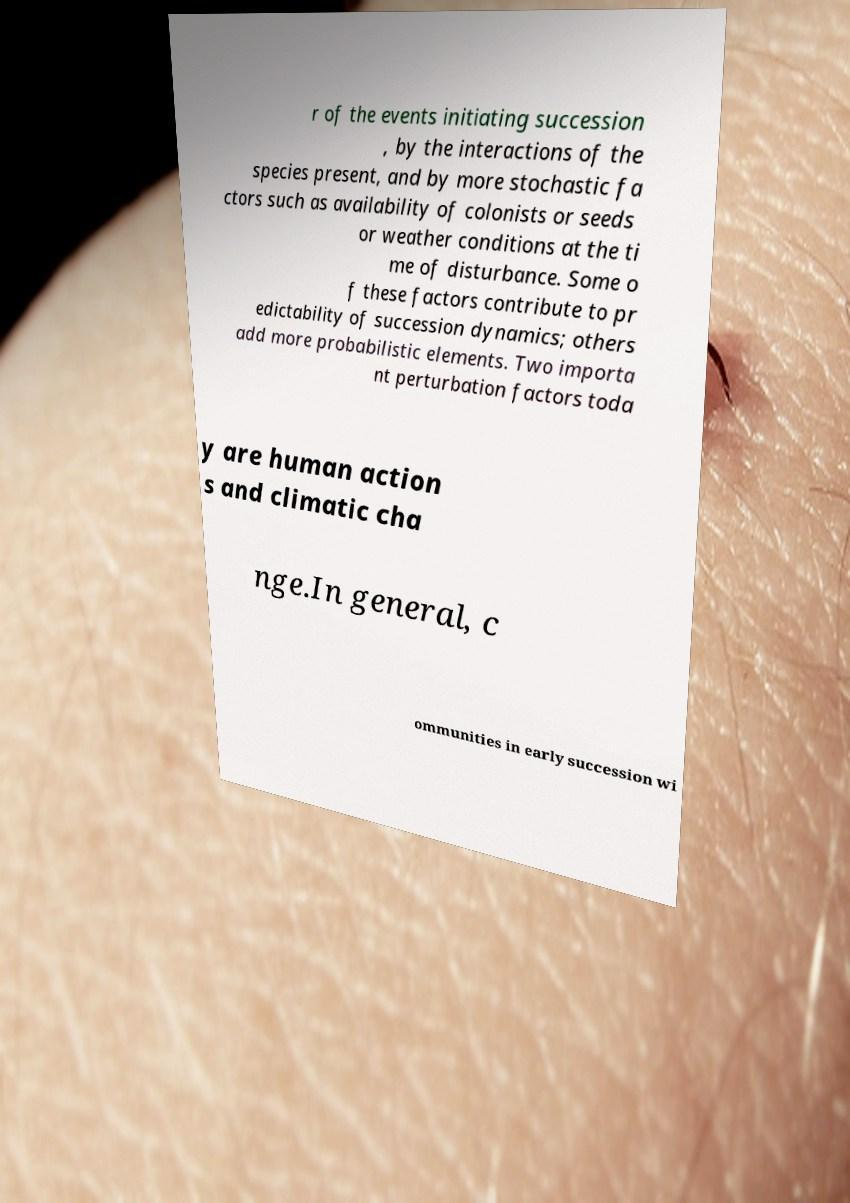I need the written content from this picture converted into text. Can you do that? r of the events initiating succession , by the interactions of the species present, and by more stochastic fa ctors such as availability of colonists or seeds or weather conditions at the ti me of disturbance. Some o f these factors contribute to pr edictability of succession dynamics; others add more probabilistic elements. Two importa nt perturbation factors toda y are human action s and climatic cha nge.In general, c ommunities in early succession wi 